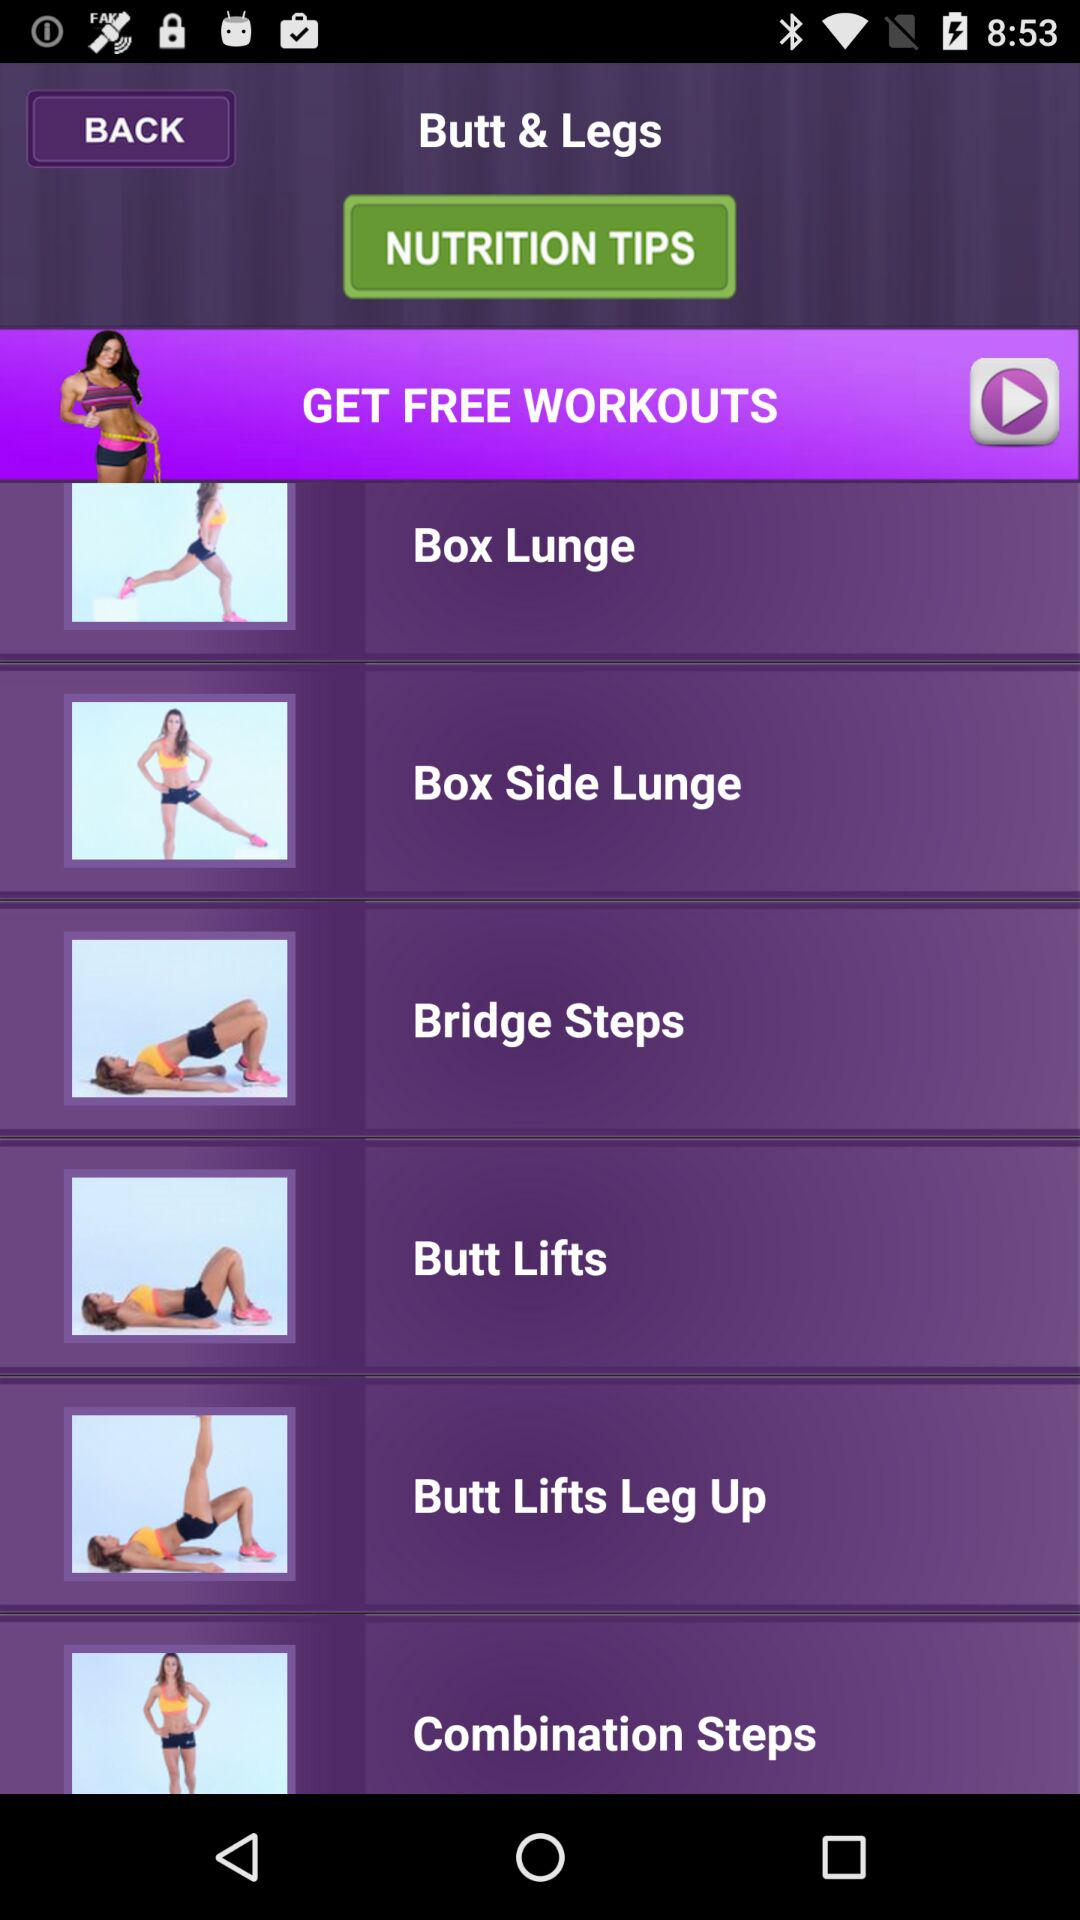How many workouts are there in total?
Answer the question using a single word or phrase. 6 